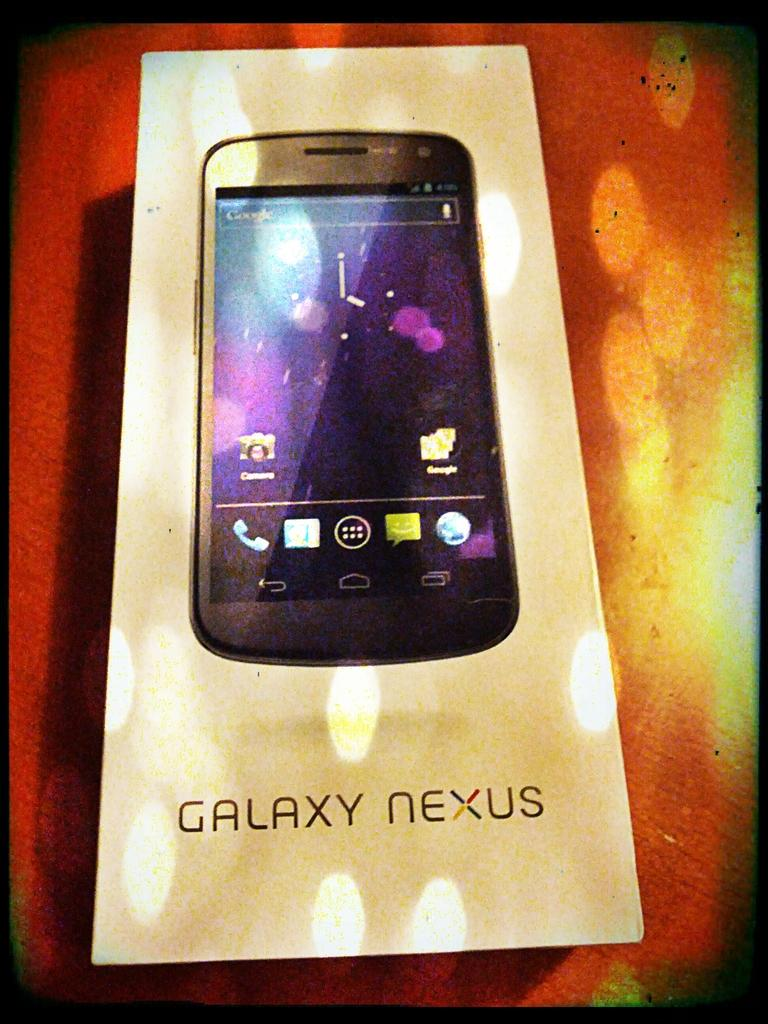<image>
Relay a brief, clear account of the picture shown. A Galaxy Nexus smart phone box on a table. 